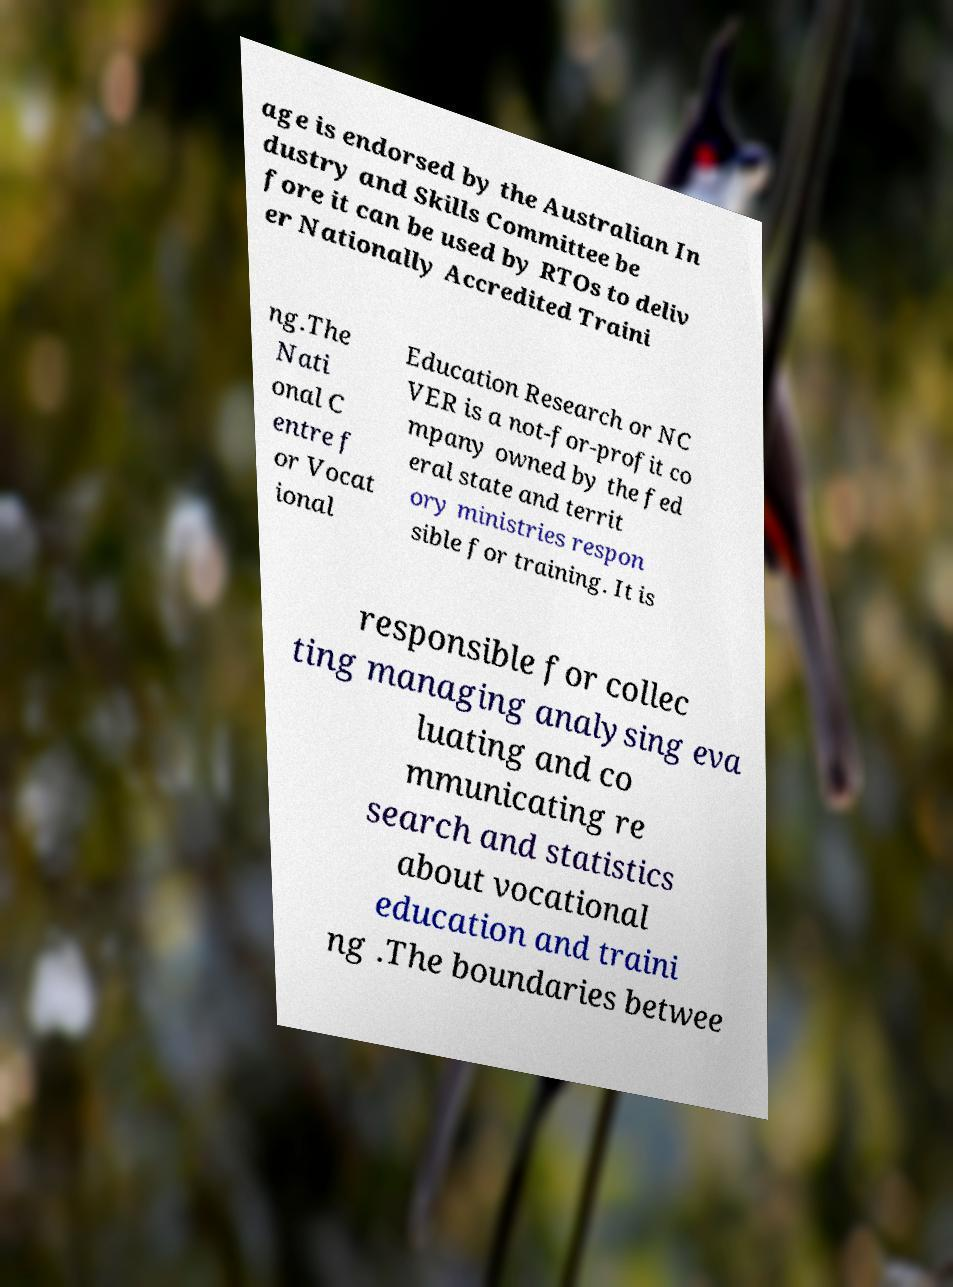Please read and relay the text visible in this image. What does it say? age is endorsed by the Australian In dustry and Skills Committee be fore it can be used by RTOs to deliv er Nationally Accredited Traini ng.The Nati onal C entre f or Vocat ional Education Research or NC VER is a not-for-profit co mpany owned by the fed eral state and territ ory ministries respon sible for training. It is responsible for collec ting managing analysing eva luating and co mmunicating re search and statistics about vocational education and traini ng .The boundaries betwee 